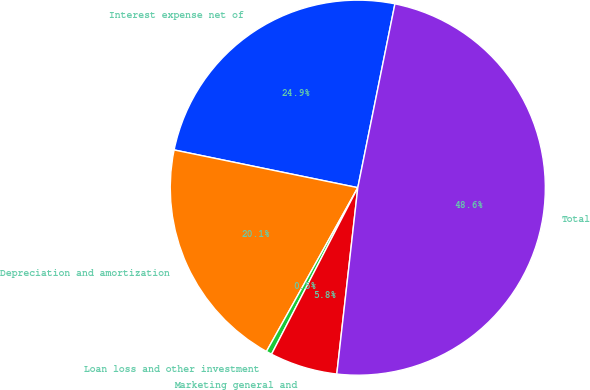<chart> <loc_0><loc_0><loc_500><loc_500><pie_chart><fcel>Interest expense net of<fcel>Depreciation and amortization<fcel>Loan loss and other investment<fcel>Marketing general and<fcel>Total<nl><fcel>24.95%<fcel>20.13%<fcel>0.49%<fcel>5.82%<fcel>48.62%<nl></chart> 